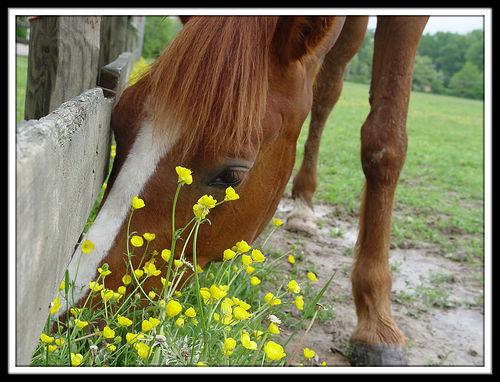Is there hay in the image?
Keep it brief. No. What color are the flowers?
Quick response, please. Yellow. What color around the horse's hooves?
Give a very brief answer. Brown. What is the horse eating?
Concise answer only. Flowers. What are the horses eating?
Be succinct. Flowers. 